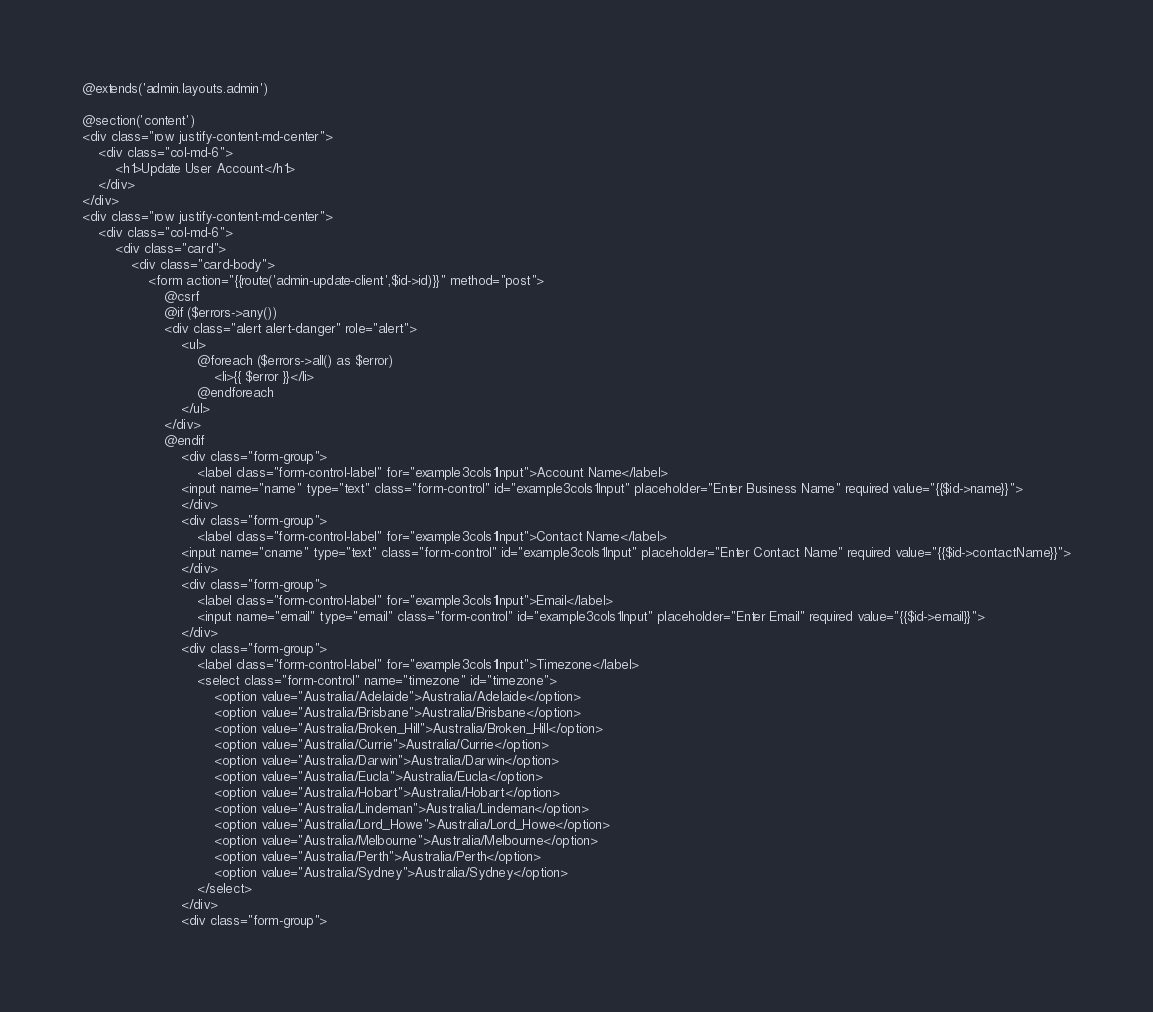<code> <loc_0><loc_0><loc_500><loc_500><_PHP_>@extends('admin.layouts.admin')

@section('content')
<div class="row justify-content-md-center">
    <div class="col-md-6">
        <h1>Update User Account</h1>
    </div>
</div>
<div class="row justify-content-md-center">
    <div class="col-md-6">
        <div class="card">
            <div class="card-body">
                <form action="{{route('admin-update-client',$id->id)}}" method="post">
                    @csrf
                    @if ($errors->any())
                    <div class="alert alert-danger" role="alert">
                        <ul>
                            @foreach ($errors->all() as $error)
                                <li>{{ $error }}</li>
                            @endforeach
                        </ul>
                    </div>
                    @endif
                        <div class="form-group">
                            <label class="form-control-label" for="example3cols1Input">Account Name</label>
                        <input name="name" type="text" class="form-control" id="example3cols1Input" placeholder="Enter Business Name" required value="{{$id->name}}">
                        </div>
                        <div class="form-group">
                            <label class="form-control-label" for="example3cols1Input">Contact Name</label>
                        <input name="cname" type="text" class="form-control" id="example3cols1Input" placeholder="Enter Contact Name" required value="{{$id->contactName}}">
                        </div>
                        <div class="form-group">
                            <label class="form-control-label" for="example3cols1Input">Email</label>
                            <input name="email" type="email" class="form-control" id="example3cols1Input" placeholder="Enter Email" required value="{{$id->email}}">
                        </div>
                        <div class="form-group">
                            <label class="form-control-label" for="example3cols1Input">Timezone</label>
                            <select class="form-control" name="timezone" id="timezone">
                                <option value="Australia/Adelaide">Australia/Adelaide</option>
                                <option value="Australia/Brisbane">Australia/Brisbane</option>
                                <option value="Australia/Broken_Hill">Australia/Broken_Hill</option>
                                <option value="Australia/Currie">Australia/Currie</option>
                                <option value="Australia/Darwin">Australia/Darwin</option>
                                <option value="Australia/Eucla">Australia/Eucla</option>
                                <option value="Australia/Hobart">Australia/Hobart</option>
                                <option value="Australia/Lindeman">Australia/Lindeman</option>
                                <option value="Australia/Lord_Howe">Australia/Lord_Howe</option>
                                <option value="Australia/Melbourne">Australia/Melbourne</option>
                                <option value="Australia/Perth">Australia/Perth</option>
                                <option value="Australia/Sydney">Australia/Sydney</option>
                            </select>
                        </div>
                        <div class="form-group"></code> 